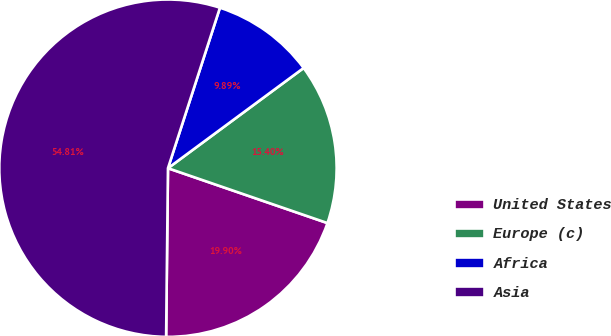<chart> <loc_0><loc_0><loc_500><loc_500><pie_chart><fcel>United States<fcel>Europe (c)<fcel>Africa<fcel>Asia<nl><fcel>19.9%<fcel>15.4%<fcel>9.89%<fcel>54.81%<nl></chart> 